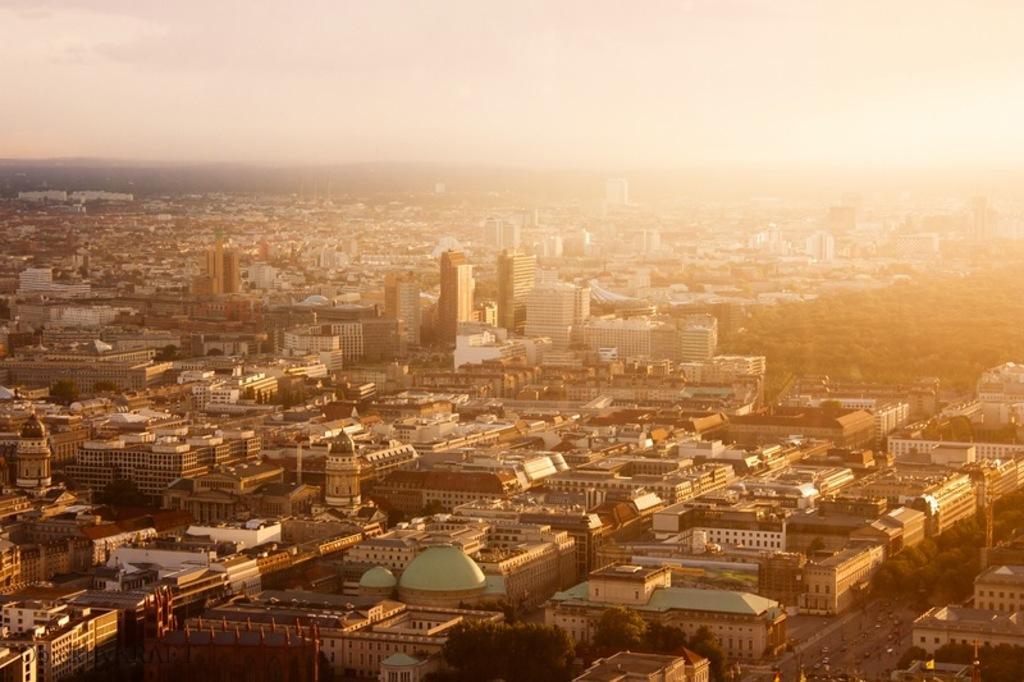Can you describe this image briefly? In this picture there are buildings and trees and there are cars moving on the road. 